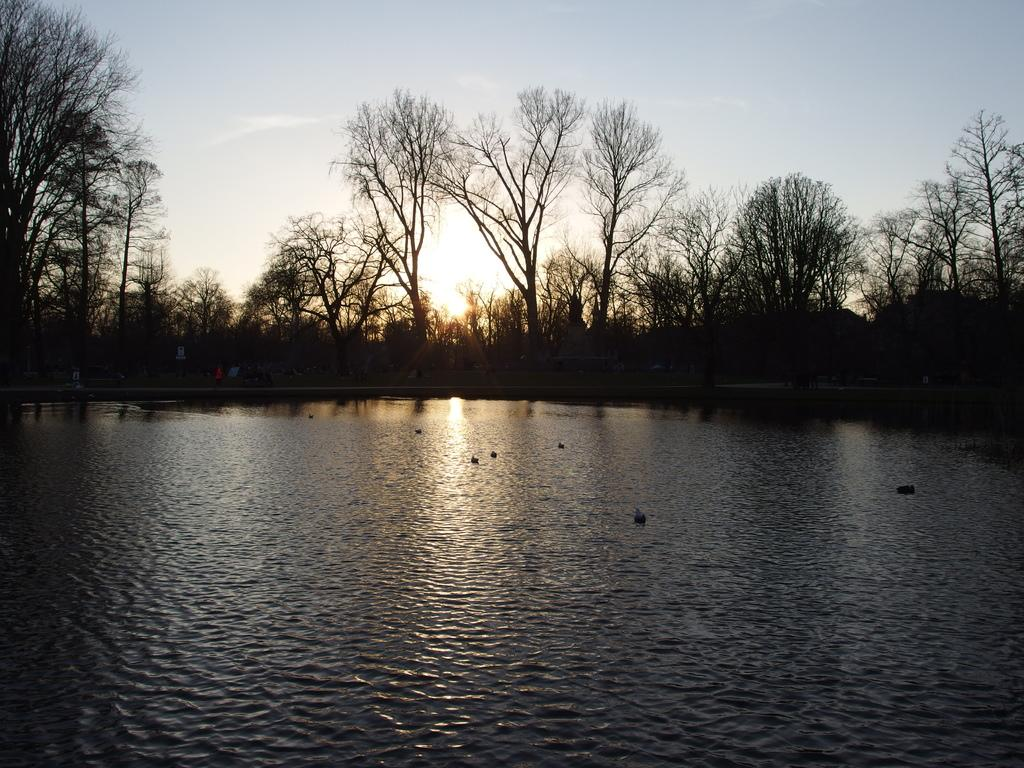What is the main feature in the foreground of the image? There is a water surface in the foreground of the image. What can be seen behind the water surface in the image? There are trees visible behind the water surface in the image. Can you describe the natural environment depicted in the image? The image features a water surface and trees, suggesting a natural setting. Reasoning: Let' Let's think step by step in order to produce the conversation. We start by identifying the main feature in the foreground, which is the water surface. Then, we describe what can be seen behind the water surface, which are trees. Finally, we combine these details to provide a general description of the natural environment depicted in the image. Absurd Question/Answer: What type of guide is present near the water surface in the image? There is no guide present in the image; it only features a water surface and trees. What is the oven used for in the image? There is no oven present in the image. 